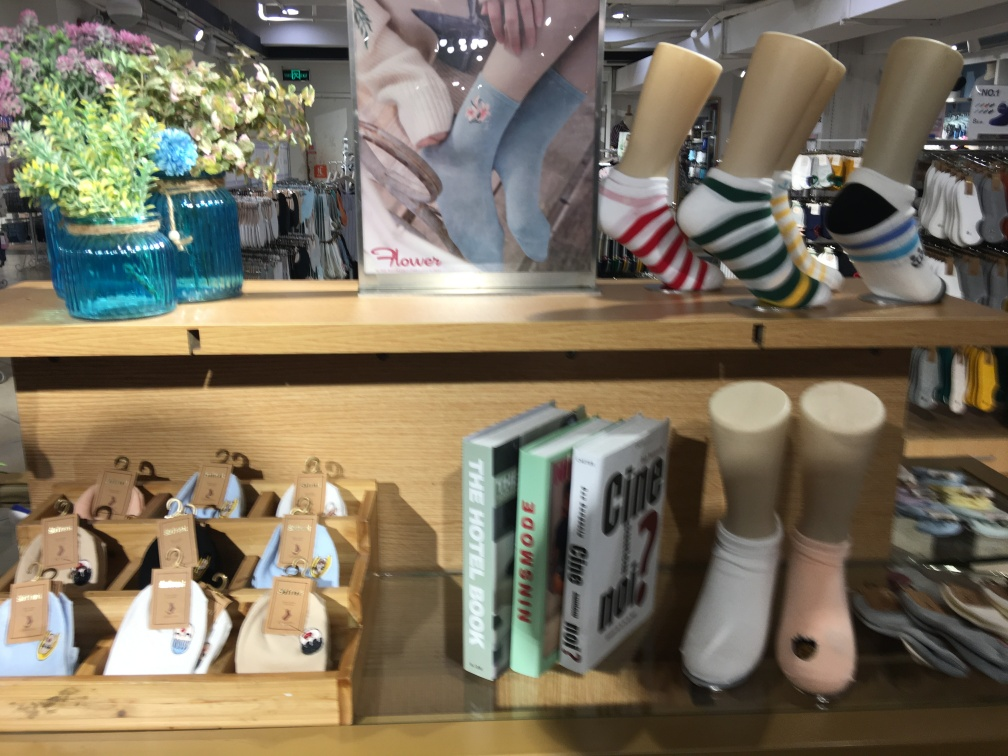What kind of items are being displayed on the shelf? The shelf displays a variety of retail items, including colorful socks on foot molds, a selection of books likely related to travel or fashion, and decorative flower vases with artificial flowers. 